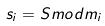Convert formula to latex. <formula><loc_0><loc_0><loc_500><loc_500>s _ { i } = S m o d m _ { i }</formula> 